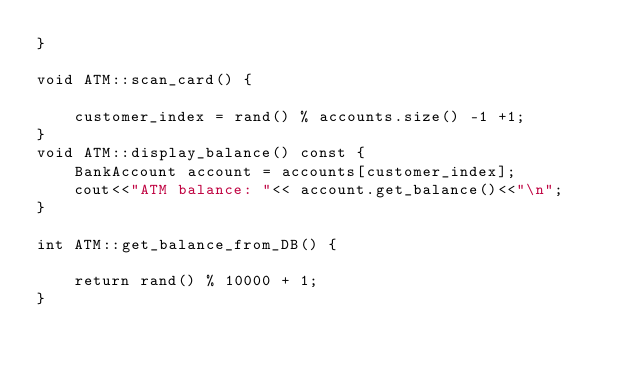Convert code to text. <code><loc_0><loc_0><loc_500><loc_500><_C++_>}

void ATM::scan_card() {

    customer_index = rand() % accounts.size() -1 +1;
}
void ATM::display_balance() const {
    BankAccount account = accounts[customer_index];
    cout<<"ATM balance: "<< account.get_balance()<<"\n";
}

int ATM::get_balance_from_DB() {

    return rand() % 10000 + 1;
}

</code> 